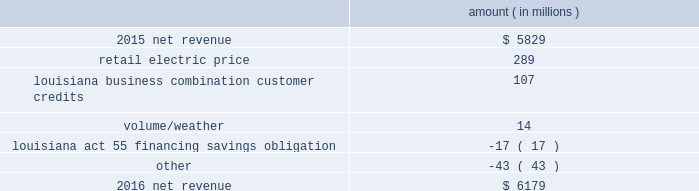( $ 66 million net-of-tax ) as a result of customer credits to be realized by electric customers of entergy louisiana , consistent with the terms of the stipulated settlement in the business combination proceeding .
See note 2 to the financial statements for further discussion of the business combination and customer credits .
Results of operations for 2015 also include the sale in december 2015 of the 583 mw rhode island state energy center for a realized gain of $ 154 million ( $ 100 million net-of-tax ) on the sale and the $ 77 million ( $ 47 million net-of-tax ) write-off and regulatory charges to recognize that a portion of the assets associated with the waterford 3 replacement steam generator project is no longer probable of recovery .
See note 14 to the financial statements for further discussion of the rhode island state energy center sale .
See note 2 to the financial statements for further discussion of the waterford 3 replacement steam generator prudence review proceeding .
Net revenue utility following is an analysis of the change in net revenue comparing 2016 to 2015 .
Amount ( in millions ) .
The retail electric price variance is primarily due to : 2022 an increase in base rates at entergy arkansas , as approved by the apsc .
The new rates were effective february 24 , 2016 and began billing with the first billing cycle of april 2016 .
The increase included an interim base rate adjustment surcharge , effective with the first billing cycle of april 2016 , to recover the incremental revenue requirement for the period february 24 , 2016 through march 31 , 2016 .
A significant portion of the increase was related to the purchase of power block 2 of the union power station ; 2022 an increase in the purchased power and capacity acquisition cost recovery rider for entergy new orleans , as approved by the city council , effective with the first billing cycle of march 2016 , primarily related to the purchase of power block 1 of the union power station ; 2022 an increase in formula rate plan revenues for entergy louisiana , implemented with the first billing cycle of march 2016 , to collect the estimated first-year revenue requirement related to the purchase of power blocks 3 and 4 of the union power station ; and 2022 an increase in revenues at entergy mississippi , as approved by the mpsc , effective with the first billing cycle of july 2016 , and an increase in revenues collected through the storm damage rider .
See note 2 to the financial statements for further discussion of the rate proceedings .
See note 14 to the financial statements for discussion of the union power station purchase .
The louisiana business combination customer credits variance is due to a regulatory liability of $ 107 million recorded by entergy in october 2015 as a result of the entergy gulf states louisiana and entergy louisiana business combination .
Consistent with the terms of the stipulated settlement in the business combination proceeding , electric customers of entergy louisiana will realize customer credits associated with the business combination ; accordingly , in october 2015 , entergy recorded a regulatory liability of $ 107 million ( $ 66 million net-of-tax ) .
These costs are being entergy corporation and subsidiaries management 2019s financial discussion and analysis .
What is the retail electric price as a percentage of net revenue in 2015? 
Computations: (289 / 5829)
Answer: 0.04958. 